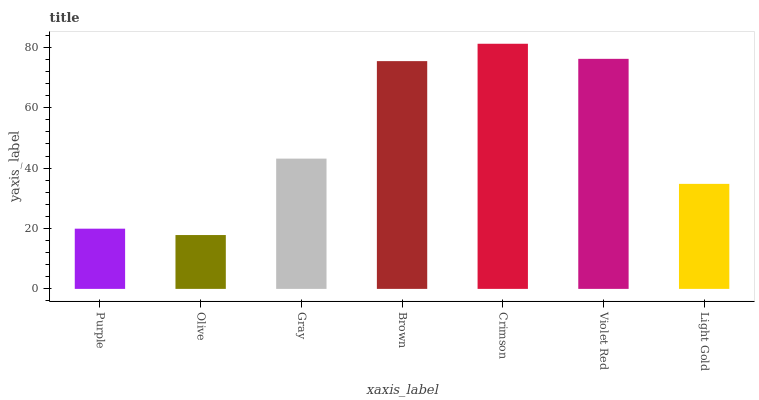Is Olive the minimum?
Answer yes or no. Yes. Is Crimson the maximum?
Answer yes or no. Yes. Is Gray the minimum?
Answer yes or no. No. Is Gray the maximum?
Answer yes or no. No. Is Gray greater than Olive?
Answer yes or no. Yes. Is Olive less than Gray?
Answer yes or no. Yes. Is Olive greater than Gray?
Answer yes or no. No. Is Gray less than Olive?
Answer yes or no. No. Is Gray the high median?
Answer yes or no. Yes. Is Gray the low median?
Answer yes or no. Yes. Is Olive the high median?
Answer yes or no. No. Is Violet Red the low median?
Answer yes or no. No. 